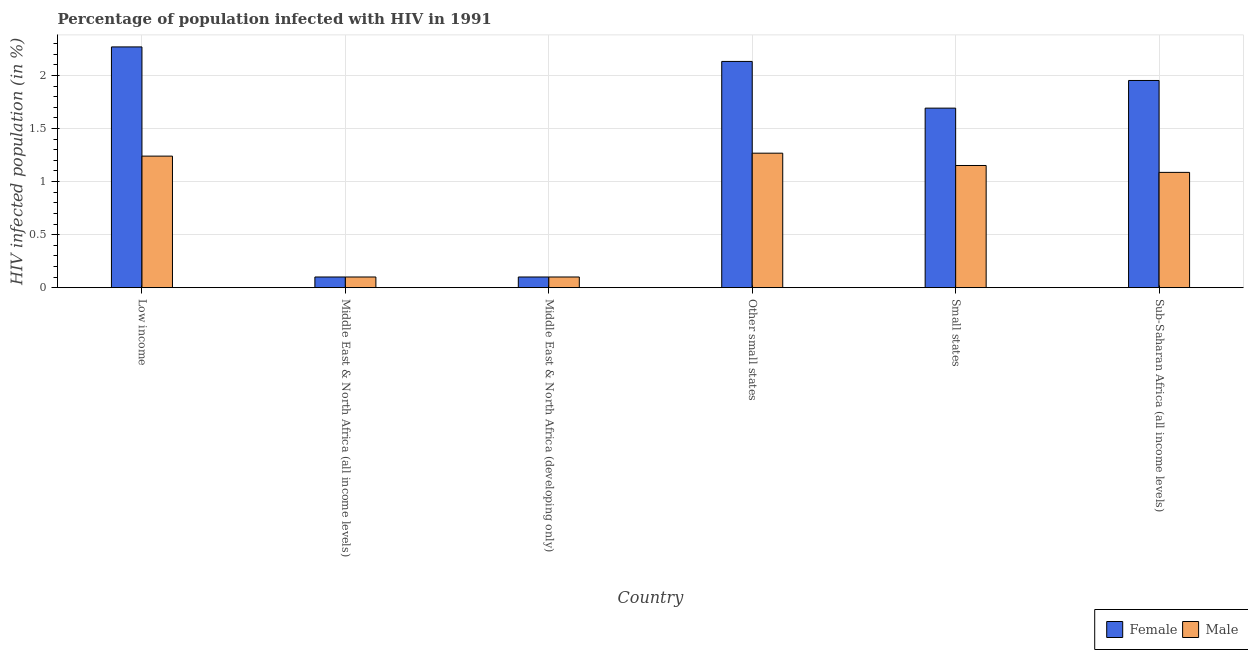Are the number of bars per tick equal to the number of legend labels?
Give a very brief answer. Yes. What is the label of the 6th group of bars from the left?
Provide a short and direct response. Sub-Saharan Africa (all income levels). In how many cases, is the number of bars for a given country not equal to the number of legend labels?
Make the answer very short. 0. What is the percentage of males who are infected with hiv in Low income?
Provide a succinct answer. 1.24. Across all countries, what is the maximum percentage of females who are infected with hiv?
Keep it short and to the point. 2.27. Across all countries, what is the minimum percentage of males who are infected with hiv?
Provide a short and direct response. 0.1. In which country was the percentage of females who are infected with hiv minimum?
Offer a very short reply. Middle East & North Africa (all income levels). What is the total percentage of females who are infected with hiv in the graph?
Provide a short and direct response. 8.25. What is the difference between the percentage of males who are infected with hiv in Middle East & North Africa (developing only) and that in Sub-Saharan Africa (all income levels)?
Offer a terse response. -0.99. What is the difference between the percentage of males who are infected with hiv in Low income and the percentage of females who are infected with hiv in Middle East & North Africa (developing only)?
Your answer should be very brief. 1.14. What is the average percentage of females who are infected with hiv per country?
Your answer should be very brief. 1.37. What is the difference between the percentage of females who are infected with hiv and percentage of males who are infected with hiv in Sub-Saharan Africa (all income levels)?
Your answer should be compact. 0.87. In how many countries, is the percentage of females who are infected with hiv greater than 1.6 %?
Provide a short and direct response. 4. What is the ratio of the percentage of males who are infected with hiv in Low income to that in Small states?
Give a very brief answer. 1.08. Is the percentage of males who are infected with hiv in Small states less than that in Sub-Saharan Africa (all income levels)?
Give a very brief answer. No. What is the difference between the highest and the second highest percentage of males who are infected with hiv?
Offer a very short reply. 0.03. What is the difference between the highest and the lowest percentage of males who are infected with hiv?
Your response must be concise. 1.17. Is the sum of the percentage of males who are infected with hiv in Middle East & North Africa (all income levels) and Sub-Saharan Africa (all income levels) greater than the maximum percentage of females who are infected with hiv across all countries?
Ensure brevity in your answer.  No. How many bars are there?
Make the answer very short. 12. Are all the bars in the graph horizontal?
Provide a short and direct response. No. How many countries are there in the graph?
Your answer should be compact. 6. What is the difference between two consecutive major ticks on the Y-axis?
Provide a succinct answer. 0.5. Are the values on the major ticks of Y-axis written in scientific E-notation?
Offer a very short reply. No. How many legend labels are there?
Ensure brevity in your answer.  2. What is the title of the graph?
Make the answer very short. Percentage of population infected with HIV in 1991. Does "Female population" appear as one of the legend labels in the graph?
Your response must be concise. No. What is the label or title of the Y-axis?
Ensure brevity in your answer.  HIV infected population (in %). What is the HIV infected population (in %) in Female in Low income?
Provide a succinct answer. 2.27. What is the HIV infected population (in %) of Male in Low income?
Give a very brief answer. 1.24. What is the HIV infected population (in %) in Female in Middle East & North Africa (all income levels)?
Ensure brevity in your answer.  0.1. What is the HIV infected population (in %) in Male in Middle East & North Africa (all income levels)?
Provide a short and direct response. 0.1. What is the HIV infected population (in %) of Female in Middle East & North Africa (developing only)?
Give a very brief answer. 0.1. What is the HIV infected population (in %) of Male in Middle East & North Africa (developing only)?
Provide a short and direct response. 0.1. What is the HIV infected population (in %) in Female in Other small states?
Make the answer very short. 2.13. What is the HIV infected population (in %) of Male in Other small states?
Offer a very short reply. 1.27. What is the HIV infected population (in %) of Female in Small states?
Ensure brevity in your answer.  1.69. What is the HIV infected population (in %) of Male in Small states?
Provide a succinct answer. 1.15. What is the HIV infected population (in %) in Female in Sub-Saharan Africa (all income levels)?
Provide a short and direct response. 1.95. What is the HIV infected population (in %) in Male in Sub-Saharan Africa (all income levels)?
Ensure brevity in your answer.  1.09. Across all countries, what is the maximum HIV infected population (in %) in Female?
Offer a very short reply. 2.27. Across all countries, what is the maximum HIV infected population (in %) in Male?
Give a very brief answer. 1.27. Across all countries, what is the minimum HIV infected population (in %) in Female?
Your answer should be compact. 0.1. Across all countries, what is the minimum HIV infected population (in %) in Male?
Your answer should be very brief. 0.1. What is the total HIV infected population (in %) in Female in the graph?
Your answer should be compact. 8.25. What is the total HIV infected population (in %) of Male in the graph?
Ensure brevity in your answer.  4.95. What is the difference between the HIV infected population (in %) of Female in Low income and that in Middle East & North Africa (all income levels)?
Offer a very short reply. 2.17. What is the difference between the HIV infected population (in %) of Male in Low income and that in Middle East & North Africa (all income levels)?
Offer a terse response. 1.14. What is the difference between the HIV infected population (in %) in Female in Low income and that in Middle East & North Africa (developing only)?
Provide a short and direct response. 2.17. What is the difference between the HIV infected population (in %) of Male in Low income and that in Middle East & North Africa (developing only)?
Ensure brevity in your answer.  1.14. What is the difference between the HIV infected population (in %) of Female in Low income and that in Other small states?
Keep it short and to the point. 0.14. What is the difference between the HIV infected population (in %) in Male in Low income and that in Other small states?
Your answer should be compact. -0.03. What is the difference between the HIV infected population (in %) in Female in Low income and that in Small states?
Provide a succinct answer. 0.58. What is the difference between the HIV infected population (in %) in Male in Low income and that in Small states?
Give a very brief answer. 0.09. What is the difference between the HIV infected population (in %) of Female in Low income and that in Sub-Saharan Africa (all income levels)?
Offer a very short reply. 0.32. What is the difference between the HIV infected population (in %) of Male in Low income and that in Sub-Saharan Africa (all income levels)?
Offer a very short reply. 0.15. What is the difference between the HIV infected population (in %) in Female in Middle East & North Africa (all income levels) and that in Other small states?
Your answer should be very brief. -2.03. What is the difference between the HIV infected population (in %) in Male in Middle East & North Africa (all income levels) and that in Other small states?
Your response must be concise. -1.17. What is the difference between the HIV infected population (in %) in Female in Middle East & North Africa (all income levels) and that in Small states?
Give a very brief answer. -1.59. What is the difference between the HIV infected population (in %) in Male in Middle East & North Africa (all income levels) and that in Small states?
Offer a terse response. -1.05. What is the difference between the HIV infected population (in %) of Female in Middle East & North Africa (all income levels) and that in Sub-Saharan Africa (all income levels)?
Provide a short and direct response. -1.85. What is the difference between the HIV infected population (in %) of Male in Middle East & North Africa (all income levels) and that in Sub-Saharan Africa (all income levels)?
Give a very brief answer. -0.99. What is the difference between the HIV infected population (in %) of Female in Middle East & North Africa (developing only) and that in Other small states?
Provide a succinct answer. -2.03. What is the difference between the HIV infected population (in %) in Male in Middle East & North Africa (developing only) and that in Other small states?
Make the answer very short. -1.17. What is the difference between the HIV infected population (in %) in Female in Middle East & North Africa (developing only) and that in Small states?
Keep it short and to the point. -1.59. What is the difference between the HIV infected population (in %) in Male in Middle East & North Africa (developing only) and that in Small states?
Make the answer very short. -1.05. What is the difference between the HIV infected population (in %) in Female in Middle East & North Africa (developing only) and that in Sub-Saharan Africa (all income levels)?
Provide a short and direct response. -1.85. What is the difference between the HIV infected population (in %) in Male in Middle East & North Africa (developing only) and that in Sub-Saharan Africa (all income levels)?
Your answer should be compact. -0.99. What is the difference between the HIV infected population (in %) in Female in Other small states and that in Small states?
Ensure brevity in your answer.  0.44. What is the difference between the HIV infected population (in %) in Male in Other small states and that in Small states?
Provide a short and direct response. 0.12. What is the difference between the HIV infected population (in %) of Female in Other small states and that in Sub-Saharan Africa (all income levels)?
Offer a very short reply. 0.18. What is the difference between the HIV infected population (in %) of Male in Other small states and that in Sub-Saharan Africa (all income levels)?
Offer a very short reply. 0.18. What is the difference between the HIV infected population (in %) of Female in Small states and that in Sub-Saharan Africa (all income levels)?
Give a very brief answer. -0.26. What is the difference between the HIV infected population (in %) of Male in Small states and that in Sub-Saharan Africa (all income levels)?
Keep it short and to the point. 0.06. What is the difference between the HIV infected population (in %) of Female in Low income and the HIV infected population (in %) of Male in Middle East & North Africa (all income levels)?
Make the answer very short. 2.17. What is the difference between the HIV infected population (in %) of Female in Low income and the HIV infected population (in %) of Male in Middle East & North Africa (developing only)?
Make the answer very short. 2.17. What is the difference between the HIV infected population (in %) in Female in Low income and the HIV infected population (in %) in Male in Small states?
Provide a short and direct response. 1.12. What is the difference between the HIV infected population (in %) of Female in Low income and the HIV infected population (in %) of Male in Sub-Saharan Africa (all income levels)?
Provide a short and direct response. 1.18. What is the difference between the HIV infected population (in %) of Female in Middle East & North Africa (all income levels) and the HIV infected population (in %) of Male in Other small states?
Your answer should be compact. -1.17. What is the difference between the HIV infected population (in %) in Female in Middle East & North Africa (all income levels) and the HIV infected population (in %) in Male in Small states?
Your response must be concise. -1.05. What is the difference between the HIV infected population (in %) in Female in Middle East & North Africa (all income levels) and the HIV infected population (in %) in Male in Sub-Saharan Africa (all income levels)?
Give a very brief answer. -0.99. What is the difference between the HIV infected population (in %) in Female in Middle East & North Africa (developing only) and the HIV infected population (in %) in Male in Other small states?
Your answer should be compact. -1.17. What is the difference between the HIV infected population (in %) of Female in Middle East & North Africa (developing only) and the HIV infected population (in %) of Male in Small states?
Your answer should be very brief. -1.05. What is the difference between the HIV infected population (in %) of Female in Middle East & North Africa (developing only) and the HIV infected population (in %) of Male in Sub-Saharan Africa (all income levels)?
Your response must be concise. -0.99. What is the difference between the HIV infected population (in %) in Female in Other small states and the HIV infected population (in %) in Male in Sub-Saharan Africa (all income levels)?
Your answer should be very brief. 1.05. What is the difference between the HIV infected population (in %) of Female in Small states and the HIV infected population (in %) of Male in Sub-Saharan Africa (all income levels)?
Your response must be concise. 0.61. What is the average HIV infected population (in %) in Female per country?
Keep it short and to the point. 1.37. What is the average HIV infected population (in %) in Male per country?
Make the answer very short. 0.82. What is the difference between the HIV infected population (in %) of Female and HIV infected population (in %) of Male in Low income?
Your answer should be very brief. 1.03. What is the difference between the HIV infected population (in %) in Female and HIV infected population (in %) in Male in Middle East & North Africa (all income levels)?
Offer a very short reply. 0. What is the difference between the HIV infected population (in %) in Female and HIV infected population (in %) in Male in Middle East & North Africa (developing only)?
Give a very brief answer. 0. What is the difference between the HIV infected population (in %) in Female and HIV infected population (in %) in Male in Other small states?
Your answer should be compact. 0.86. What is the difference between the HIV infected population (in %) in Female and HIV infected population (in %) in Male in Small states?
Keep it short and to the point. 0.54. What is the difference between the HIV infected population (in %) of Female and HIV infected population (in %) of Male in Sub-Saharan Africa (all income levels)?
Provide a succinct answer. 0.87. What is the ratio of the HIV infected population (in %) of Female in Low income to that in Middle East & North Africa (all income levels)?
Ensure brevity in your answer.  22.55. What is the ratio of the HIV infected population (in %) of Male in Low income to that in Middle East & North Africa (all income levels)?
Your response must be concise. 12.32. What is the ratio of the HIV infected population (in %) of Female in Low income to that in Middle East & North Africa (developing only)?
Make the answer very short. 22.55. What is the ratio of the HIV infected population (in %) in Male in Low income to that in Middle East & North Africa (developing only)?
Your response must be concise. 12.32. What is the ratio of the HIV infected population (in %) of Female in Low income to that in Other small states?
Give a very brief answer. 1.06. What is the ratio of the HIV infected population (in %) of Male in Low income to that in Other small states?
Offer a very short reply. 0.98. What is the ratio of the HIV infected population (in %) in Female in Low income to that in Small states?
Give a very brief answer. 1.34. What is the ratio of the HIV infected population (in %) in Male in Low income to that in Small states?
Make the answer very short. 1.08. What is the ratio of the HIV infected population (in %) of Female in Low income to that in Sub-Saharan Africa (all income levels)?
Provide a short and direct response. 1.16. What is the ratio of the HIV infected population (in %) of Male in Low income to that in Sub-Saharan Africa (all income levels)?
Offer a very short reply. 1.14. What is the ratio of the HIV infected population (in %) of Male in Middle East & North Africa (all income levels) to that in Middle East & North Africa (developing only)?
Keep it short and to the point. 1. What is the ratio of the HIV infected population (in %) of Female in Middle East & North Africa (all income levels) to that in Other small states?
Offer a very short reply. 0.05. What is the ratio of the HIV infected population (in %) of Male in Middle East & North Africa (all income levels) to that in Other small states?
Make the answer very short. 0.08. What is the ratio of the HIV infected population (in %) of Female in Middle East & North Africa (all income levels) to that in Small states?
Provide a succinct answer. 0.06. What is the ratio of the HIV infected population (in %) in Male in Middle East & North Africa (all income levels) to that in Small states?
Provide a short and direct response. 0.09. What is the ratio of the HIV infected population (in %) of Female in Middle East & North Africa (all income levels) to that in Sub-Saharan Africa (all income levels)?
Keep it short and to the point. 0.05. What is the ratio of the HIV infected population (in %) in Male in Middle East & North Africa (all income levels) to that in Sub-Saharan Africa (all income levels)?
Give a very brief answer. 0.09. What is the ratio of the HIV infected population (in %) of Female in Middle East & North Africa (developing only) to that in Other small states?
Your answer should be compact. 0.05. What is the ratio of the HIV infected population (in %) of Male in Middle East & North Africa (developing only) to that in Other small states?
Your answer should be very brief. 0.08. What is the ratio of the HIV infected population (in %) in Female in Middle East & North Africa (developing only) to that in Small states?
Offer a very short reply. 0.06. What is the ratio of the HIV infected population (in %) of Male in Middle East & North Africa (developing only) to that in Small states?
Provide a succinct answer. 0.09. What is the ratio of the HIV infected population (in %) in Female in Middle East & North Africa (developing only) to that in Sub-Saharan Africa (all income levels)?
Provide a succinct answer. 0.05. What is the ratio of the HIV infected population (in %) of Male in Middle East & North Africa (developing only) to that in Sub-Saharan Africa (all income levels)?
Your answer should be very brief. 0.09. What is the ratio of the HIV infected population (in %) in Female in Other small states to that in Small states?
Make the answer very short. 1.26. What is the ratio of the HIV infected population (in %) in Male in Other small states to that in Small states?
Your response must be concise. 1.1. What is the ratio of the HIV infected population (in %) in Female in Other small states to that in Sub-Saharan Africa (all income levels)?
Ensure brevity in your answer.  1.09. What is the ratio of the HIV infected population (in %) in Male in Other small states to that in Sub-Saharan Africa (all income levels)?
Make the answer very short. 1.17. What is the ratio of the HIV infected population (in %) in Female in Small states to that in Sub-Saharan Africa (all income levels)?
Keep it short and to the point. 0.87. What is the ratio of the HIV infected population (in %) of Male in Small states to that in Sub-Saharan Africa (all income levels)?
Your answer should be very brief. 1.06. What is the difference between the highest and the second highest HIV infected population (in %) of Female?
Your response must be concise. 0.14. What is the difference between the highest and the second highest HIV infected population (in %) in Male?
Your answer should be compact. 0.03. What is the difference between the highest and the lowest HIV infected population (in %) of Female?
Ensure brevity in your answer.  2.17. What is the difference between the highest and the lowest HIV infected population (in %) in Male?
Your answer should be compact. 1.17. 